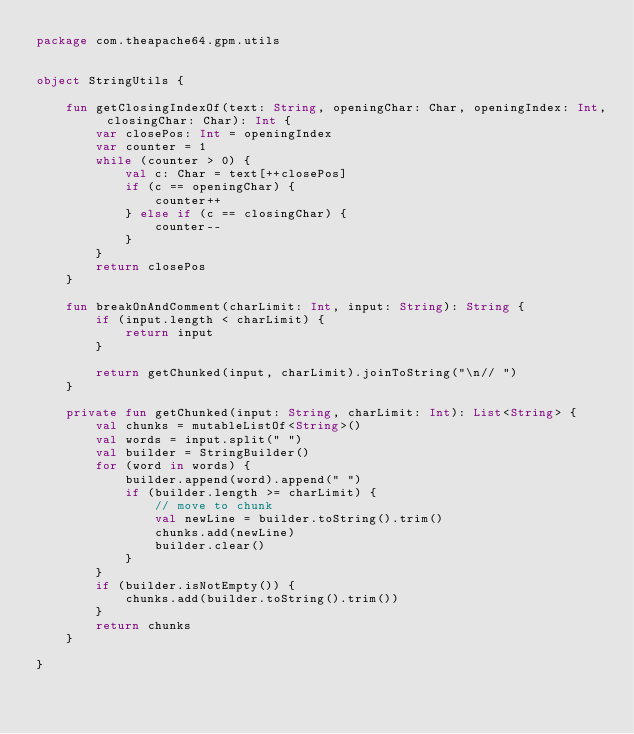<code> <loc_0><loc_0><loc_500><loc_500><_Kotlin_>package com.theapache64.gpm.utils


object StringUtils {

    fun getClosingIndexOf(text: String, openingChar: Char, openingIndex: Int, closingChar: Char): Int {
        var closePos: Int = openingIndex
        var counter = 1
        while (counter > 0) {
            val c: Char = text[++closePos]
            if (c == openingChar) {
                counter++
            } else if (c == closingChar) {
                counter--
            }
        }
        return closePos
    }

    fun breakOnAndComment(charLimit: Int, input: String): String {
        if (input.length < charLimit) {
            return input
        }

        return getChunked(input, charLimit).joinToString("\n// ")
    }

    private fun getChunked(input: String, charLimit: Int): List<String> {
        val chunks = mutableListOf<String>()
        val words = input.split(" ")
        val builder = StringBuilder()
        for (word in words) {
            builder.append(word).append(" ")
            if (builder.length >= charLimit) {
                // move to chunk
                val newLine = builder.toString().trim()
                chunks.add(newLine)
                builder.clear()
            }
        }
        if (builder.isNotEmpty()) {
            chunks.add(builder.toString().trim())
        }
        return chunks
    }

}</code> 